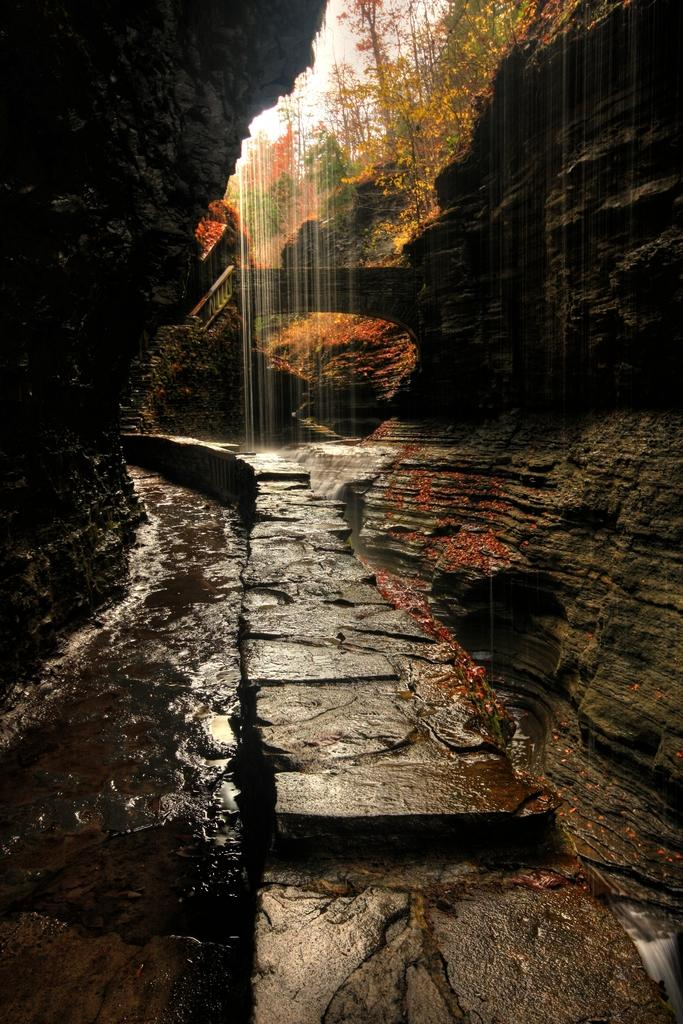What natural feature is the main subject of the image? There is a waterfall in the image. What is the waterfall situated on? The waterfall is on rocks. What can be seen in the background of the image? There are trees and the sky visible in the background of the image. How many bees can be seen collecting nectar from the waterfall in the image? There are no bees present in the image, as the waterfall is not a source of nectar for bees. 